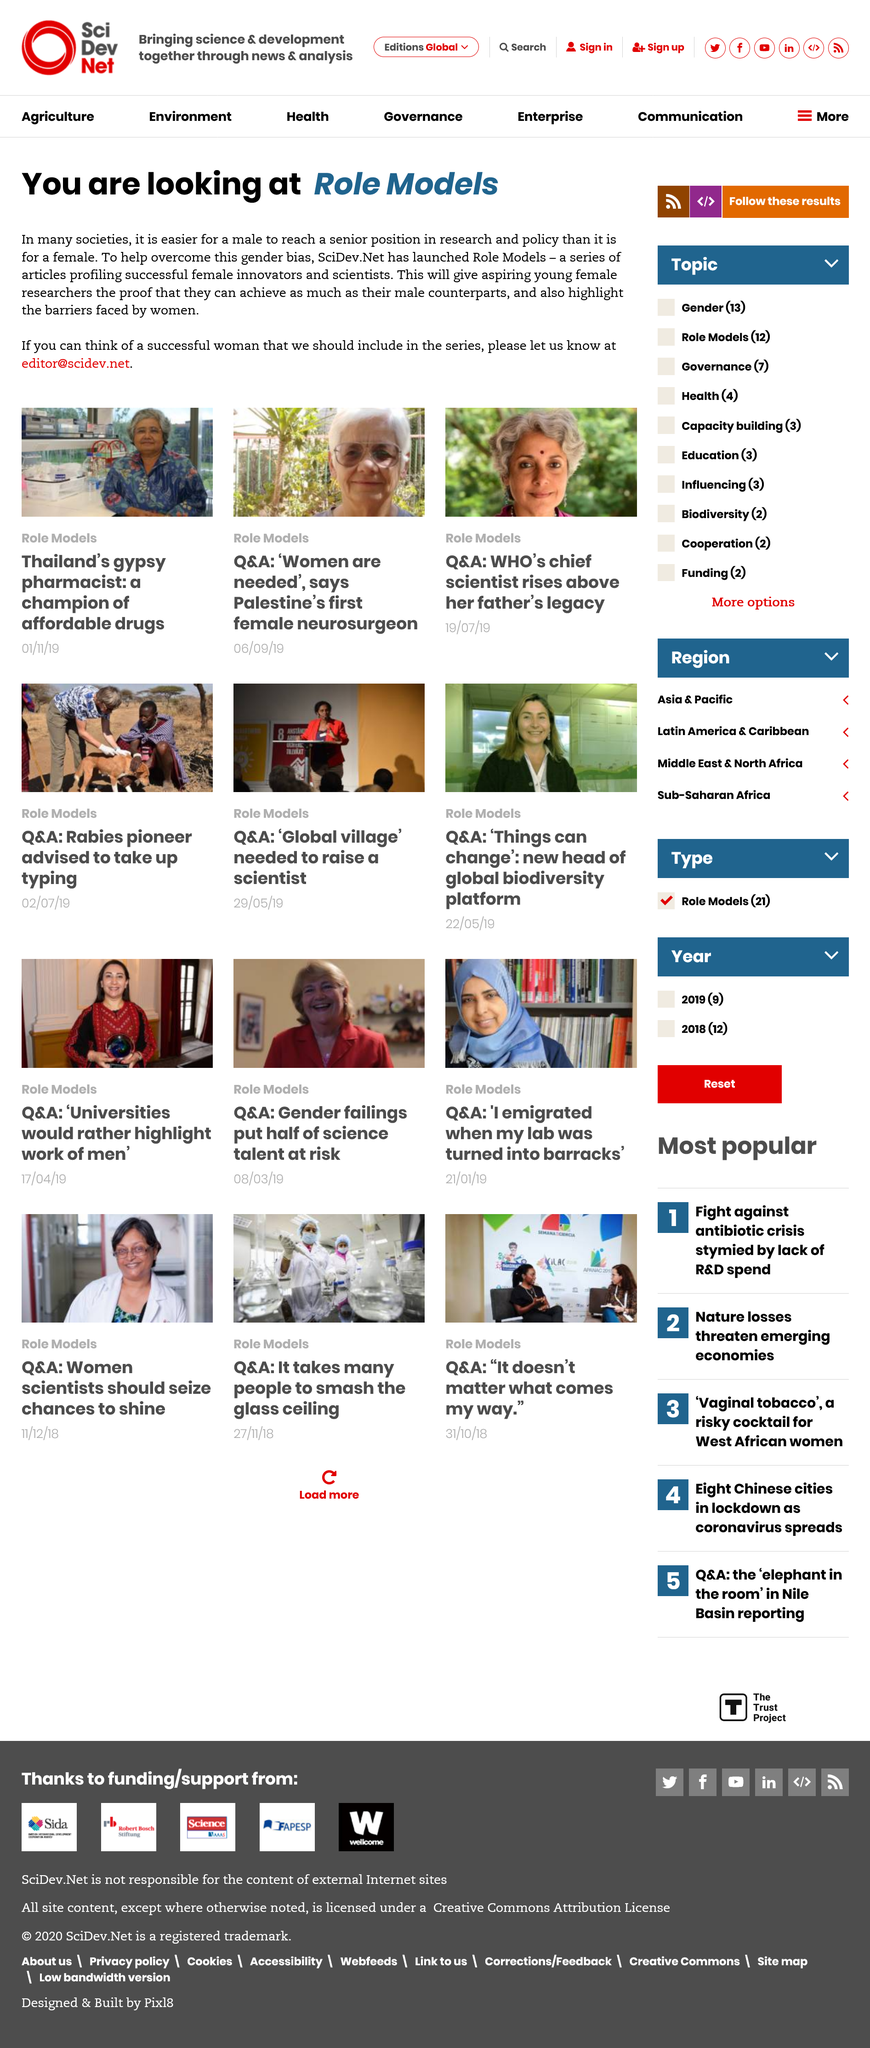Outline some significant characteristics in this image. The articles are featuring females. You recommend reaching out to them via email to propose featuring a female role model in their content. The women featured in this article work in the science industry. 